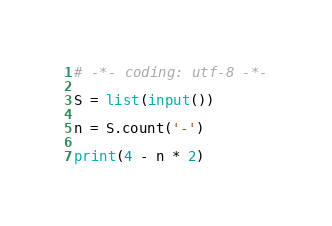<code> <loc_0><loc_0><loc_500><loc_500><_Python_># -*- coding: utf-8 -*-

S = list(input())

n = S.count('-')

print(4 - n * 2)</code> 